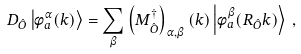<formula> <loc_0><loc_0><loc_500><loc_500>D _ { \hat { O } } \left | \phi _ { a } ^ { \alpha } ( k ) \right \rangle = \sum _ { \beta } \left ( M ^ { \dagger } _ { \hat { O } } \right ) _ { \alpha , \beta } ( k ) \left | \phi _ { a } ^ { \beta } ( R _ { \hat { O } } k ) \right \rangle \, ,</formula> 